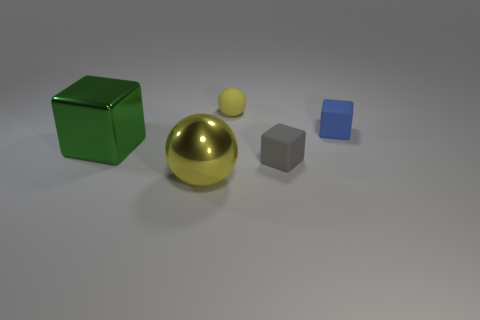What is the material of the green object that is the same size as the yellow metal object?
Ensure brevity in your answer.  Metal. Is there a metallic object that has the same size as the blue rubber thing?
Offer a very short reply. No. There is a small thing on the left side of the gray object; is it the same color as the small cube behind the tiny gray cube?
Your response must be concise. No. How many metallic things are either large things or small red things?
Make the answer very short. 2. How many yellow metal objects are behind the small object that is behind the cube behind the big green metallic thing?
Make the answer very short. 0. There is a gray object that is made of the same material as the blue cube; what is its size?
Keep it short and to the point. Small. How many large matte cylinders are the same color as the matte ball?
Provide a short and direct response. 0. There is a yellow thing that is behind the blue matte thing; is it the same size as the metal ball?
Keep it short and to the point. No. There is a cube that is to the right of the metallic ball and in front of the blue block; what color is it?
Your answer should be compact. Gray. How many objects are either shiny blocks or rubber objects that are behind the small gray rubber object?
Provide a short and direct response. 3. 